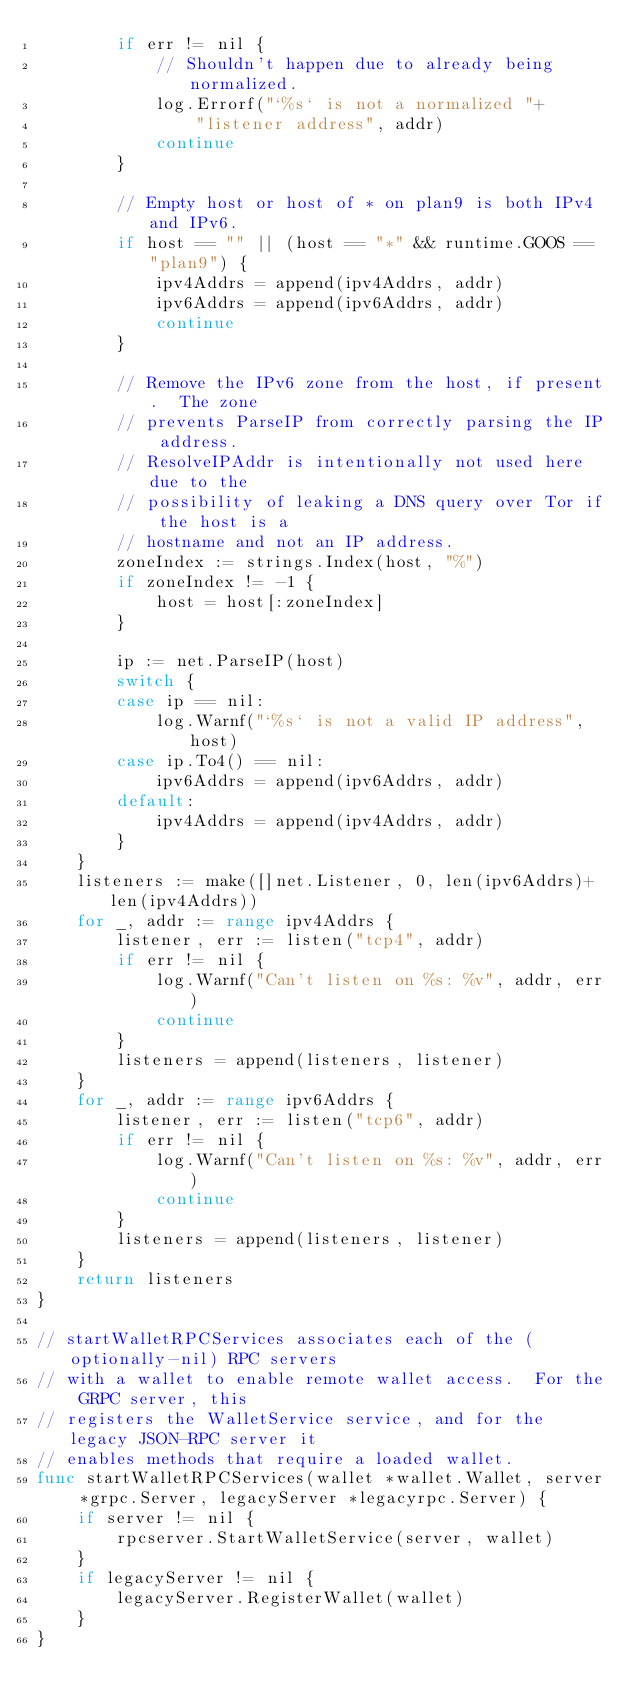Convert code to text. <code><loc_0><loc_0><loc_500><loc_500><_Go_>		if err != nil {
			// Shouldn't happen due to already being normalized.
			log.Errorf("`%s` is not a normalized "+
				"listener address", addr)
			continue
		}

		// Empty host or host of * on plan9 is both IPv4 and IPv6.
		if host == "" || (host == "*" && runtime.GOOS == "plan9") {
			ipv4Addrs = append(ipv4Addrs, addr)
			ipv6Addrs = append(ipv6Addrs, addr)
			continue
		}

		// Remove the IPv6 zone from the host, if present.  The zone
		// prevents ParseIP from correctly parsing the IP address.
		// ResolveIPAddr is intentionally not used here due to the
		// possibility of leaking a DNS query over Tor if the host is a
		// hostname and not an IP address.
		zoneIndex := strings.Index(host, "%")
		if zoneIndex != -1 {
			host = host[:zoneIndex]
		}

		ip := net.ParseIP(host)
		switch {
		case ip == nil:
			log.Warnf("`%s` is not a valid IP address", host)
		case ip.To4() == nil:
			ipv6Addrs = append(ipv6Addrs, addr)
		default:
			ipv4Addrs = append(ipv4Addrs, addr)
		}
	}
	listeners := make([]net.Listener, 0, len(ipv6Addrs)+len(ipv4Addrs))
	for _, addr := range ipv4Addrs {
		listener, err := listen("tcp4", addr)
		if err != nil {
			log.Warnf("Can't listen on %s: %v", addr, err)
			continue
		}
		listeners = append(listeners, listener)
	}
	for _, addr := range ipv6Addrs {
		listener, err := listen("tcp6", addr)
		if err != nil {
			log.Warnf("Can't listen on %s: %v", addr, err)
			continue
		}
		listeners = append(listeners, listener)
	}
	return listeners
}

// startWalletRPCServices associates each of the (optionally-nil) RPC servers
// with a wallet to enable remote wallet access.  For the GRPC server, this
// registers the WalletService service, and for the legacy JSON-RPC server it
// enables methods that require a loaded wallet.
func startWalletRPCServices(wallet *wallet.Wallet, server *grpc.Server, legacyServer *legacyrpc.Server) {
	if server != nil {
		rpcserver.StartWalletService(server, wallet)
	}
	if legacyServer != nil {
		legacyServer.RegisterWallet(wallet)
	}
}
</code> 